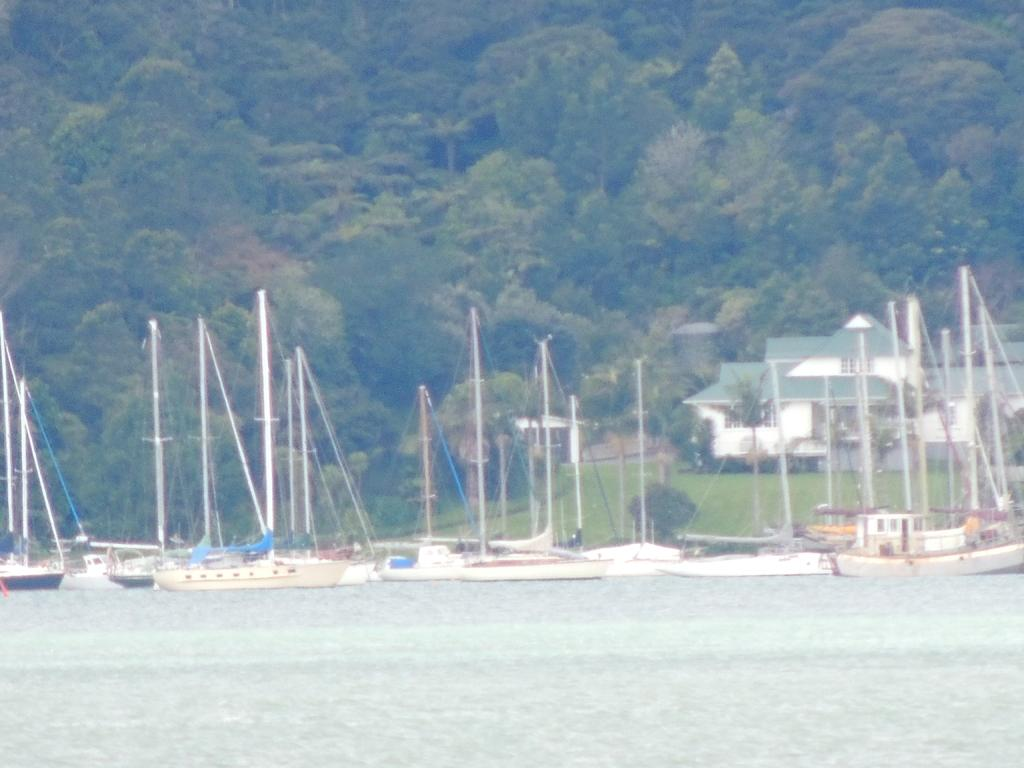What type of vehicles can be seen in the image? There are boats in the image. What is the primary element in which the boats are situated? There is water in the image, and the boats are situated in it. What type of vegetation is present in the image? There are plants and trees in the image. What type of terrain can be seen in the image? There is grass in the image, suggesting a grassy area. What type of structure is visible in the image? There is a house in the image. What type of fuel is used by the belief in the image? There is no mention of a belief or fuel in the image; it features boats in water, grass, plants, trees, and a house. 